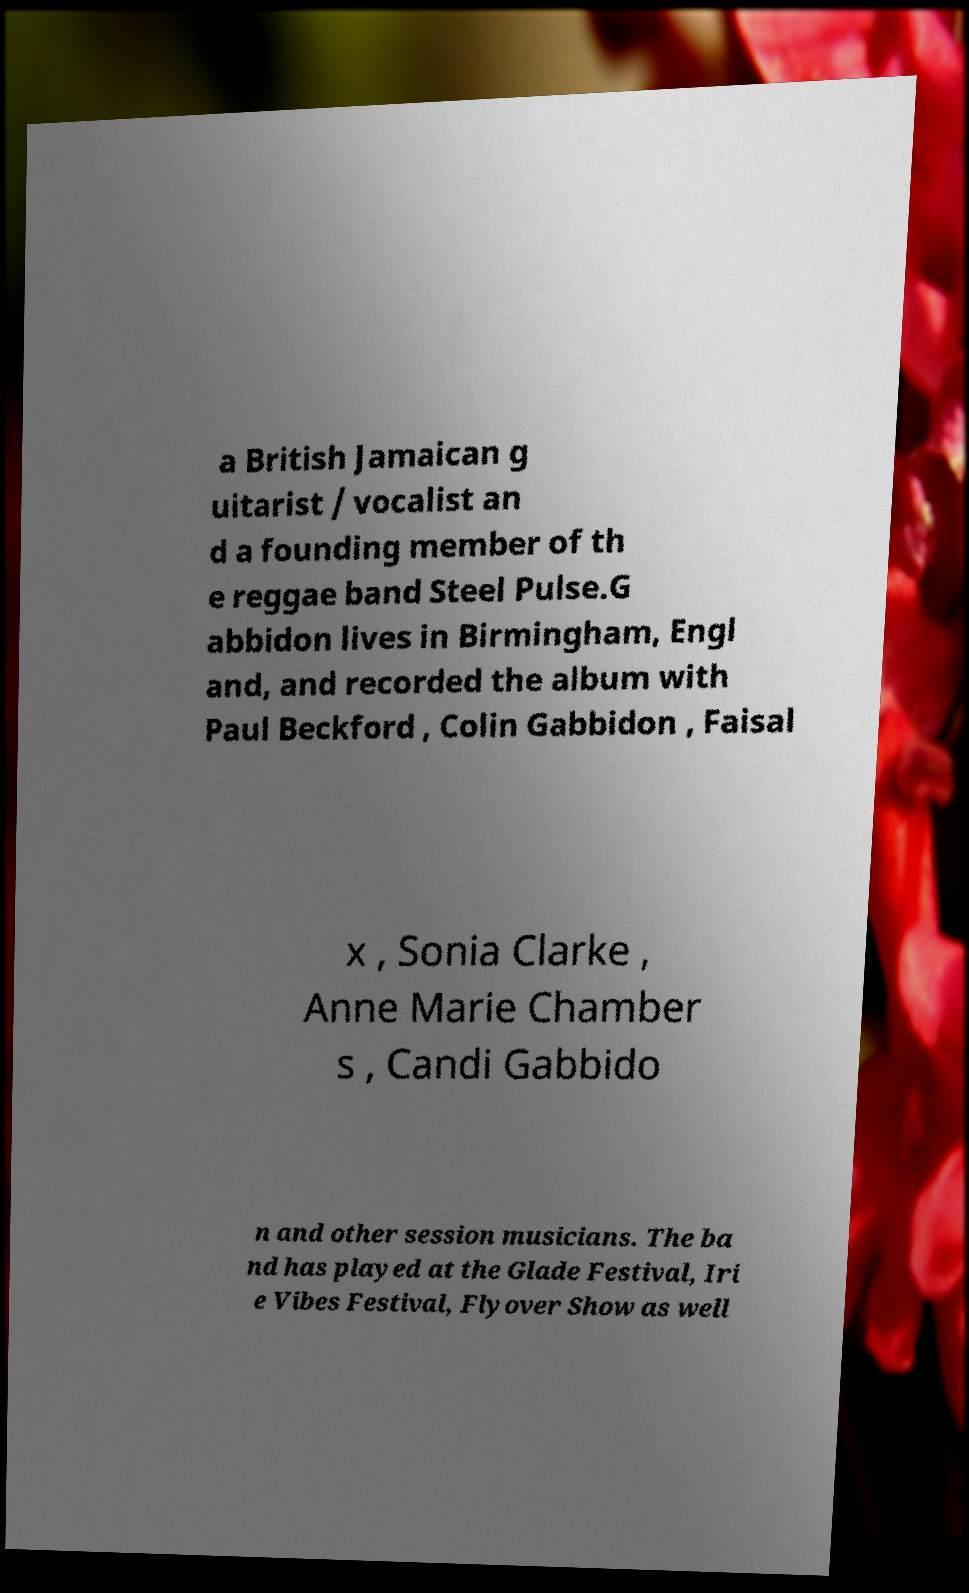I need the written content from this picture converted into text. Can you do that? a British Jamaican g uitarist / vocalist an d a founding member of th e reggae band Steel Pulse.G abbidon lives in Birmingham, Engl and, and recorded the album with Paul Beckford , Colin Gabbidon , Faisal x , Sonia Clarke , Anne Marie Chamber s , Candi Gabbido n and other session musicians. The ba nd has played at the Glade Festival, Iri e Vibes Festival, Flyover Show as well 